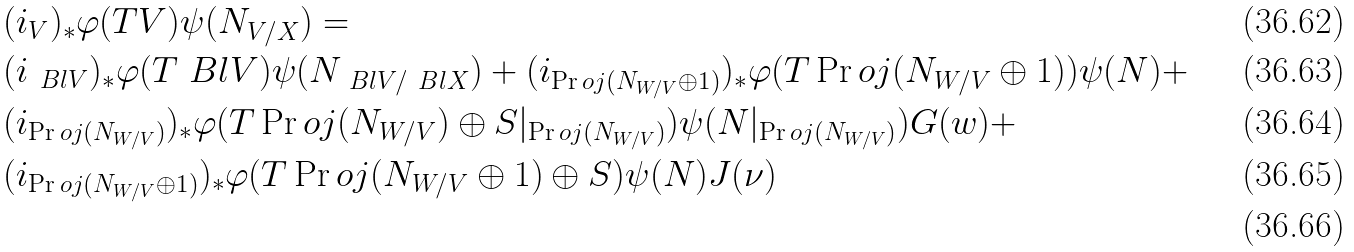<formula> <loc_0><loc_0><loc_500><loc_500>& ( i _ { V } ) _ { * } \varphi ( T V ) \psi ( N _ { V / X } ) = \\ & ( i _ { \ B l { V } } ) _ { * } \varphi ( T \ B l { V } ) \psi ( N _ { \ B l { V } / \ B l { X } } ) + ( i _ { \Pr o j ( N _ { W / V } \oplus 1 ) } ) _ { * } \varphi ( T \Pr o j ( N _ { W / V } \oplus 1 ) ) \psi ( N ) + \\ & ( i _ { \Pr o j ( N _ { W / V } ) } ) _ { * } \varphi ( T \Pr o j ( N _ { W / V } ) \oplus S | _ { \Pr o j ( N _ { W / V } ) } ) \psi ( N | _ { \Pr o j ( N _ { W / V } ) } ) G ( w ) + \\ & ( i _ { \Pr o j ( N _ { W / V } \oplus 1 ) } ) _ { * } \varphi ( T \Pr o j ( N _ { W / V } \oplus 1 ) \oplus S ) \psi ( N ) J ( \nu ) \\</formula> 